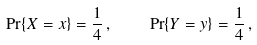<formula> <loc_0><loc_0><loc_500><loc_500>\Pr \{ X = x \} = \frac { 1 } { 4 } \, , \quad \Pr \{ Y = y \} = \frac { 1 } { 4 } \, ,</formula> 